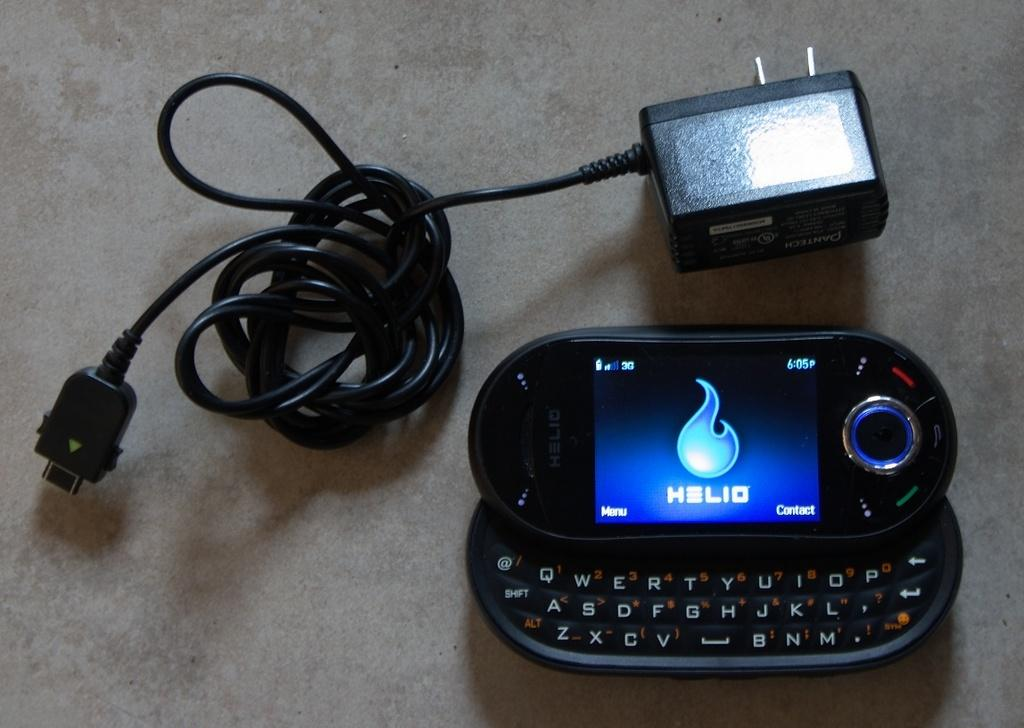<image>
Describe the image concisely. a cell phone displaying Helio on the screen 